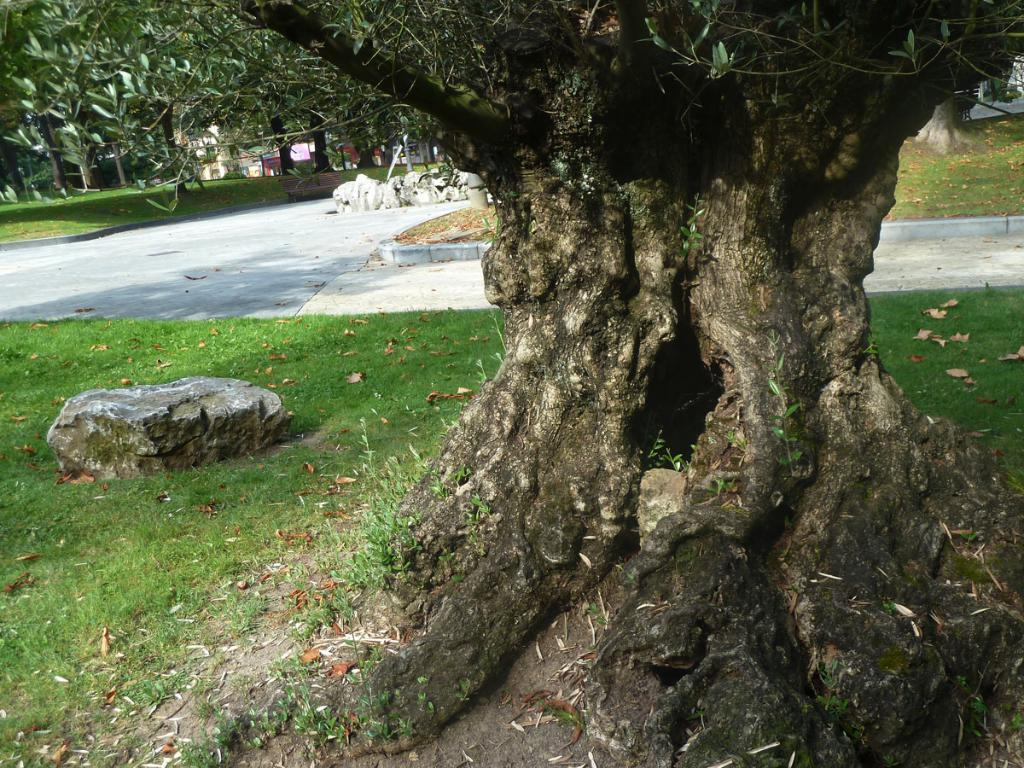What type of natural object can be seen in the image? There is a tree trunk in the image. What other natural objects can be seen in the image? There is a rock and grass in the image. Are there any other trees visible in the image? Yes, there are trees in the image. What type of comb is being used by the band in the image? There is no band or comb present in the image; it features a tree trunk, a rock, grass, and trees. What type of relation can be seen between the trees in the image? There is no indication of a relation between the trees in the image; they are simply depicted as separate objects. 